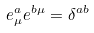Convert formula to latex. <formula><loc_0><loc_0><loc_500><loc_500>e _ { \mu } ^ { a } e ^ { b \mu } = \delta ^ { a b }</formula> 